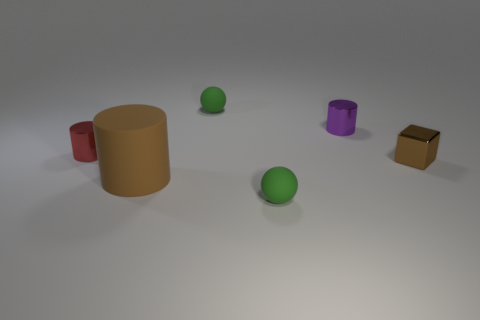Add 1 small green metal things. How many objects exist? 7 Subtract all big brown cylinders. How many cylinders are left? 2 Add 3 big blue cubes. How many big blue cubes exist? 3 Subtract all brown cylinders. How many cylinders are left? 2 Subtract 0 red blocks. How many objects are left? 6 Subtract all spheres. How many objects are left? 4 Subtract 1 balls. How many balls are left? 1 Subtract all brown cylinders. Subtract all gray blocks. How many cylinders are left? 2 Subtract all red spheres. How many brown cylinders are left? 1 Subtract all tiny cubes. Subtract all large cyan balls. How many objects are left? 5 